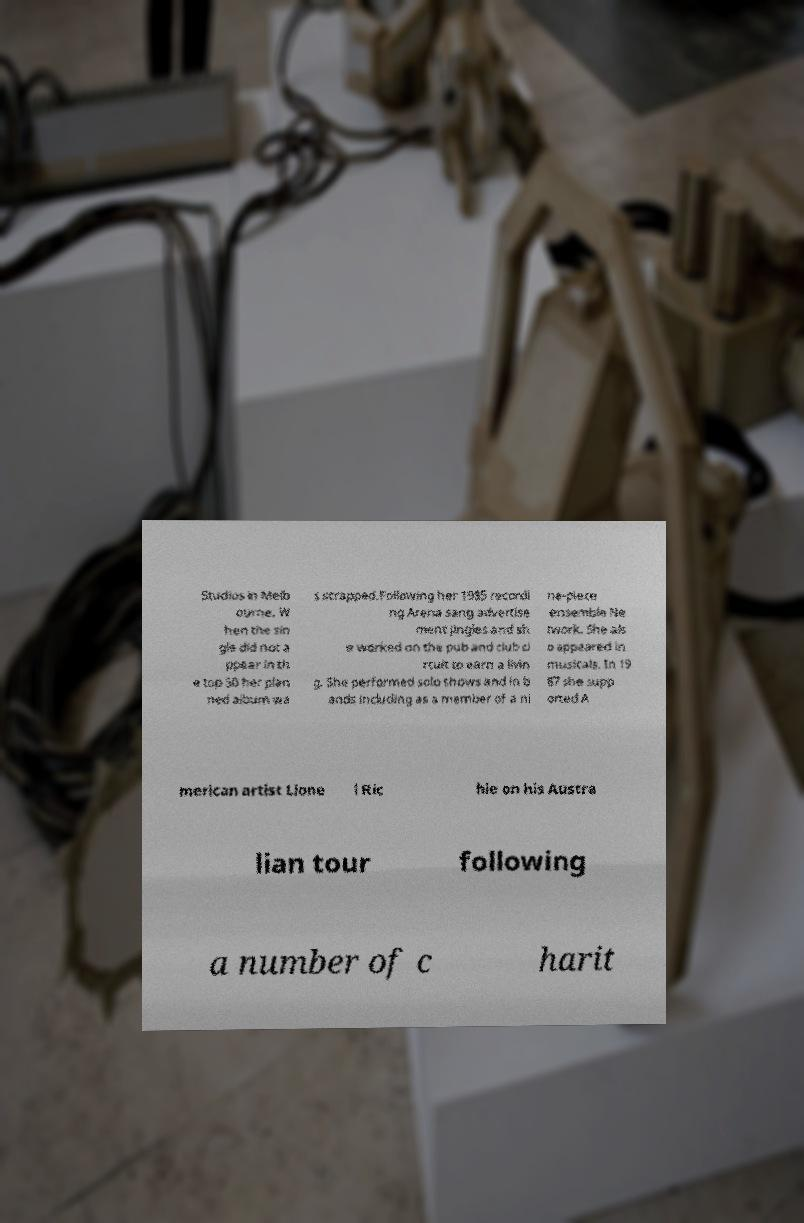Could you assist in decoding the text presented in this image and type it out clearly? Studios in Melb ourne. W hen the sin gle did not a ppear in th e top 50 her plan ned album wa s scrapped.Following her 1985 recordi ng Arena sang advertise ment jingles and sh e worked on the pub and club ci rcuit to earn a livin g. She performed solo shows and in b ands including as a member of a ni ne-piece ensemble Ne twork. She als o appeared in musicals. In 19 87 she supp orted A merican artist Lione l Ric hie on his Austra lian tour following a number of c harit 